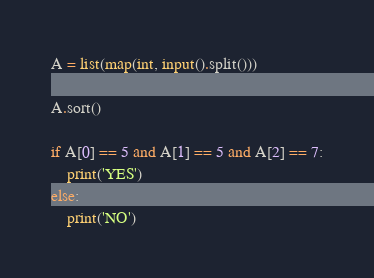<code> <loc_0><loc_0><loc_500><loc_500><_Python_>A = list(map(int, input().split()))

A.sort()

if A[0] == 5 and A[1] == 5 and A[2] == 7:
    print('YES')
else:
    print('NO')
</code> 